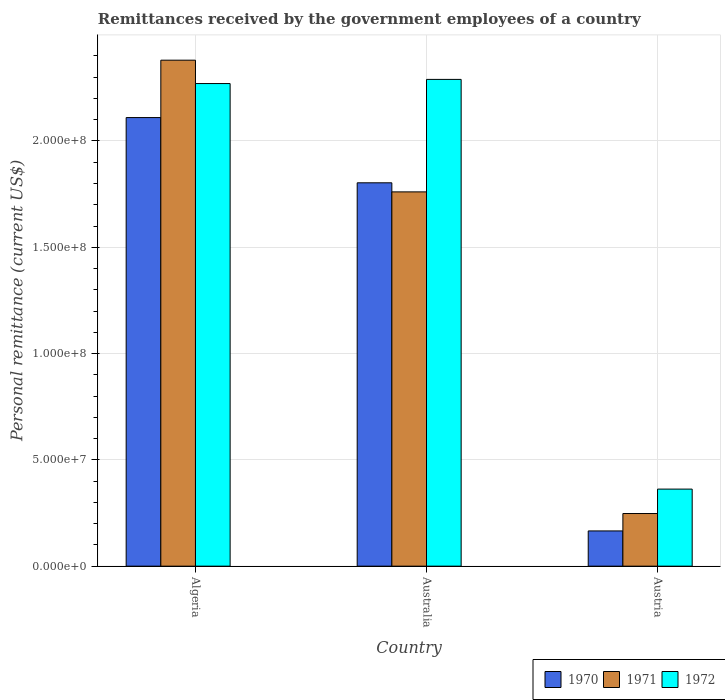How many groups of bars are there?
Make the answer very short. 3. Are the number of bars per tick equal to the number of legend labels?
Offer a terse response. Yes. Are the number of bars on each tick of the X-axis equal?
Your answer should be very brief. Yes. How many bars are there on the 2nd tick from the left?
Provide a succinct answer. 3. How many bars are there on the 2nd tick from the right?
Make the answer very short. 3. What is the label of the 3rd group of bars from the left?
Give a very brief answer. Austria. What is the remittances received by the government employees in 1970 in Austria?
Keep it short and to the point. 1.66e+07. Across all countries, what is the maximum remittances received by the government employees in 1972?
Your response must be concise. 2.29e+08. Across all countries, what is the minimum remittances received by the government employees in 1970?
Offer a very short reply. 1.66e+07. In which country was the remittances received by the government employees in 1972 maximum?
Provide a short and direct response. Australia. What is the total remittances received by the government employees in 1971 in the graph?
Offer a very short reply. 4.39e+08. What is the difference between the remittances received by the government employees in 1970 in Australia and that in Austria?
Provide a succinct answer. 1.64e+08. What is the difference between the remittances received by the government employees in 1972 in Austria and the remittances received by the government employees in 1970 in Australia?
Your answer should be very brief. -1.44e+08. What is the average remittances received by the government employees in 1970 per country?
Offer a terse response. 1.36e+08. What is the difference between the remittances received by the government employees of/in 1971 and remittances received by the government employees of/in 1972 in Austria?
Give a very brief answer. -1.15e+07. In how many countries, is the remittances received by the government employees in 1970 greater than 230000000 US$?
Keep it short and to the point. 0. What is the ratio of the remittances received by the government employees in 1971 in Algeria to that in Australia?
Your answer should be very brief. 1.35. Is the remittances received by the government employees in 1972 in Algeria less than that in Austria?
Your answer should be compact. No. What is the difference between the highest and the second highest remittances received by the government employees in 1972?
Make the answer very short. -1.96e+06. What is the difference between the highest and the lowest remittances received by the government employees in 1970?
Keep it short and to the point. 1.94e+08. What does the 1st bar from the left in Austria represents?
Offer a terse response. 1970. What does the 3rd bar from the right in Algeria represents?
Your answer should be compact. 1970. Is it the case that in every country, the sum of the remittances received by the government employees in 1970 and remittances received by the government employees in 1972 is greater than the remittances received by the government employees in 1971?
Your answer should be very brief. Yes. How many bars are there?
Provide a short and direct response. 9. Are all the bars in the graph horizontal?
Ensure brevity in your answer.  No. How many countries are there in the graph?
Provide a succinct answer. 3. Are the values on the major ticks of Y-axis written in scientific E-notation?
Offer a terse response. Yes. Does the graph contain grids?
Offer a terse response. Yes. Where does the legend appear in the graph?
Provide a short and direct response. Bottom right. What is the title of the graph?
Your answer should be very brief. Remittances received by the government employees of a country. Does "1998" appear as one of the legend labels in the graph?
Keep it short and to the point. No. What is the label or title of the Y-axis?
Your answer should be very brief. Personal remittance (current US$). What is the Personal remittance (current US$) in 1970 in Algeria?
Provide a short and direct response. 2.11e+08. What is the Personal remittance (current US$) of 1971 in Algeria?
Keep it short and to the point. 2.38e+08. What is the Personal remittance (current US$) of 1972 in Algeria?
Give a very brief answer. 2.27e+08. What is the Personal remittance (current US$) in 1970 in Australia?
Keep it short and to the point. 1.80e+08. What is the Personal remittance (current US$) of 1971 in Australia?
Your answer should be compact. 1.76e+08. What is the Personal remittance (current US$) of 1972 in Australia?
Your answer should be compact. 2.29e+08. What is the Personal remittance (current US$) in 1970 in Austria?
Your answer should be compact. 1.66e+07. What is the Personal remittance (current US$) in 1971 in Austria?
Offer a terse response. 2.48e+07. What is the Personal remittance (current US$) of 1972 in Austria?
Offer a terse response. 3.62e+07. Across all countries, what is the maximum Personal remittance (current US$) of 1970?
Make the answer very short. 2.11e+08. Across all countries, what is the maximum Personal remittance (current US$) of 1971?
Provide a short and direct response. 2.38e+08. Across all countries, what is the maximum Personal remittance (current US$) of 1972?
Your answer should be compact. 2.29e+08. Across all countries, what is the minimum Personal remittance (current US$) in 1970?
Your response must be concise. 1.66e+07. Across all countries, what is the minimum Personal remittance (current US$) of 1971?
Keep it short and to the point. 2.48e+07. Across all countries, what is the minimum Personal remittance (current US$) in 1972?
Offer a terse response. 3.62e+07. What is the total Personal remittance (current US$) of 1970 in the graph?
Ensure brevity in your answer.  4.08e+08. What is the total Personal remittance (current US$) in 1971 in the graph?
Make the answer very short. 4.39e+08. What is the total Personal remittance (current US$) of 1972 in the graph?
Your answer should be very brief. 4.92e+08. What is the difference between the Personal remittance (current US$) in 1970 in Algeria and that in Australia?
Offer a terse response. 3.07e+07. What is the difference between the Personal remittance (current US$) in 1971 in Algeria and that in Australia?
Your response must be concise. 6.20e+07. What is the difference between the Personal remittance (current US$) of 1972 in Algeria and that in Australia?
Give a very brief answer. -1.96e+06. What is the difference between the Personal remittance (current US$) in 1970 in Algeria and that in Austria?
Offer a very short reply. 1.94e+08. What is the difference between the Personal remittance (current US$) in 1971 in Algeria and that in Austria?
Your response must be concise. 2.13e+08. What is the difference between the Personal remittance (current US$) in 1972 in Algeria and that in Austria?
Your answer should be very brief. 1.91e+08. What is the difference between the Personal remittance (current US$) of 1970 in Australia and that in Austria?
Keep it short and to the point. 1.64e+08. What is the difference between the Personal remittance (current US$) of 1971 in Australia and that in Austria?
Provide a short and direct response. 1.51e+08. What is the difference between the Personal remittance (current US$) of 1972 in Australia and that in Austria?
Your answer should be very brief. 1.93e+08. What is the difference between the Personal remittance (current US$) in 1970 in Algeria and the Personal remittance (current US$) in 1971 in Australia?
Offer a very short reply. 3.50e+07. What is the difference between the Personal remittance (current US$) of 1970 in Algeria and the Personal remittance (current US$) of 1972 in Australia?
Your answer should be very brief. -1.80e+07. What is the difference between the Personal remittance (current US$) in 1971 in Algeria and the Personal remittance (current US$) in 1972 in Australia?
Offer a terse response. 9.04e+06. What is the difference between the Personal remittance (current US$) in 1970 in Algeria and the Personal remittance (current US$) in 1971 in Austria?
Provide a short and direct response. 1.86e+08. What is the difference between the Personal remittance (current US$) of 1970 in Algeria and the Personal remittance (current US$) of 1972 in Austria?
Offer a very short reply. 1.75e+08. What is the difference between the Personal remittance (current US$) of 1971 in Algeria and the Personal remittance (current US$) of 1972 in Austria?
Provide a succinct answer. 2.02e+08. What is the difference between the Personal remittance (current US$) in 1970 in Australia and the Personal remittance (current US$) in 1971 in Austria?
Provide a short and direct response. 1.56e+08. What is the difference between the Personal remittance (current US$) in 1970 in Australia and the Personal remittance (current US$) in 1972 in Austria?
Your answer should be very brief. 1.44e+08. What is the difference between the Personal remittance (current US$) in 1971 in Australia and the Personal remittance (current US$) in 1972 in Austria?
Offer a terse response. 1.40e+08. What is the average Personal remittance (current US$) in 1970 per country?
Make the answer very short. 1.36e+08. What is the average Personal remittance (current US$) of 1971 per country?
Provide a short and direct response. 1.46e+08. What is the average Personal remittance (current US$) in 1972 per country?
Offer a terse response. 1.64e+08. What is the difference between the Personal remittance (current US$) in 1970 and Personal remittance (current US$) in 1971 in Algeria?
Offer a terse response. -2.70e+07. What is the difference between the Personal remittance (current US$) of 1970 and Personal remittance (current US$) of 1972 in Algeria?
Your response must be concise. -1.60e+07. What is the difference between the Personal remittance (current US$) in 1971 and Personal remittance (current US$) in 1972 in Algeria?
Offer a terse response. 1.10e+07. What is the difference between the Personal remittance (current US$) in 1970 and Personal remittance (current US$) in 1971 in Australia?
Provide a succinct answer. 4.27e+06. What is the difference between the Personal remittance (current US$) of 1970 and Personal remittance (current US$) of 1972 in Australia?
Ensure brevity in your answer.  -4.86e+07. What is the difference between the Personal remittance (current US$) of 1971 and Personal remittance (current US$) of 1972 in Australia?
Your answer should be very brief. -5.29e+07. What is the difference between the Personal remittance (current US$) of 1970 and Personal remittance (current US$) of 1971 in Austria?
Keep it short and to the point. -8.18e+06. What is the difference between the Personal remittance (current US$) in 1970 and Personal remittance (current US$) in 1972 in Austria?
Your answer should be compact. -1.97e+07. What is the difference between the Personal remittance (current US$) of 1971 and Personal remittance (current US$) of 1972 in Austria?
Provide a succinct answer. -1.15e+07. What is the ratio of the Personal remittance (current US$) in 1970 in Algeria to that in Australia?
Provide a short and direct response. 1.17. What is the ratio of the Personal remittance (current US$) in 1971 in Algeria to that in Australia?
Give a very brief answer. 1.35. What is the ratio of the Personal remittance (current US$) in 1972 in Algeria to that in Australia?
Your answer should be very brief. 0.99. What is the ratio of the Personal remittance (current US$) in 1970 in Algeria to that in Austria?
Provide a short and direct response. 12.73. What is the ratio of the Personal remittance (current US$) of 1971 in Algeria to that in Austria?
Your answer should be compact. 9.61. What is the ratio of the Personal remittance (current US$) in 1972 in Algeria to that in Austria?
Your response must be concise. 6.26. What is the ratio of the Personal remittance (current US$) in 1970 in Australia to that in Austria?
Provide a short and direct response. 10.88. What is the ratio of the Personal remittance (current US$) in 1971 in Australia to that in Austria?
Make the answer very short. 7.11. What is the ratio of the Personal remittance (current US$) of 1972 in Australia to that in Austria?
Offer a terse response. 6.32. What is the difference between the highest and the second highest Personal remittance (current US$) in 1970?
Make the answer very short. 3.07e+07. What is the difference between the highest and the second highest Personal remittance (current US$) of 1971?
Ensure brevity in your answer.  6.20e+07. What is the difference between the highest and the second highest Personal remittance (current US$) in 1972?
Your answer should be compact. 1.96e+06. What is the difference between the highest and the lowest Personal remittance (current US$) in 1970?
Make the answer very short. 1.94e+08. What is the difference between the highest and the lowest Personal remittance (current US$) of 1971?
Your answer should be very brief. 2.13e+08. What is the difference between the highest and the lowest Personal remittance (current US$) of 1972?
Keep it short and to the point. 1.93e+08. 